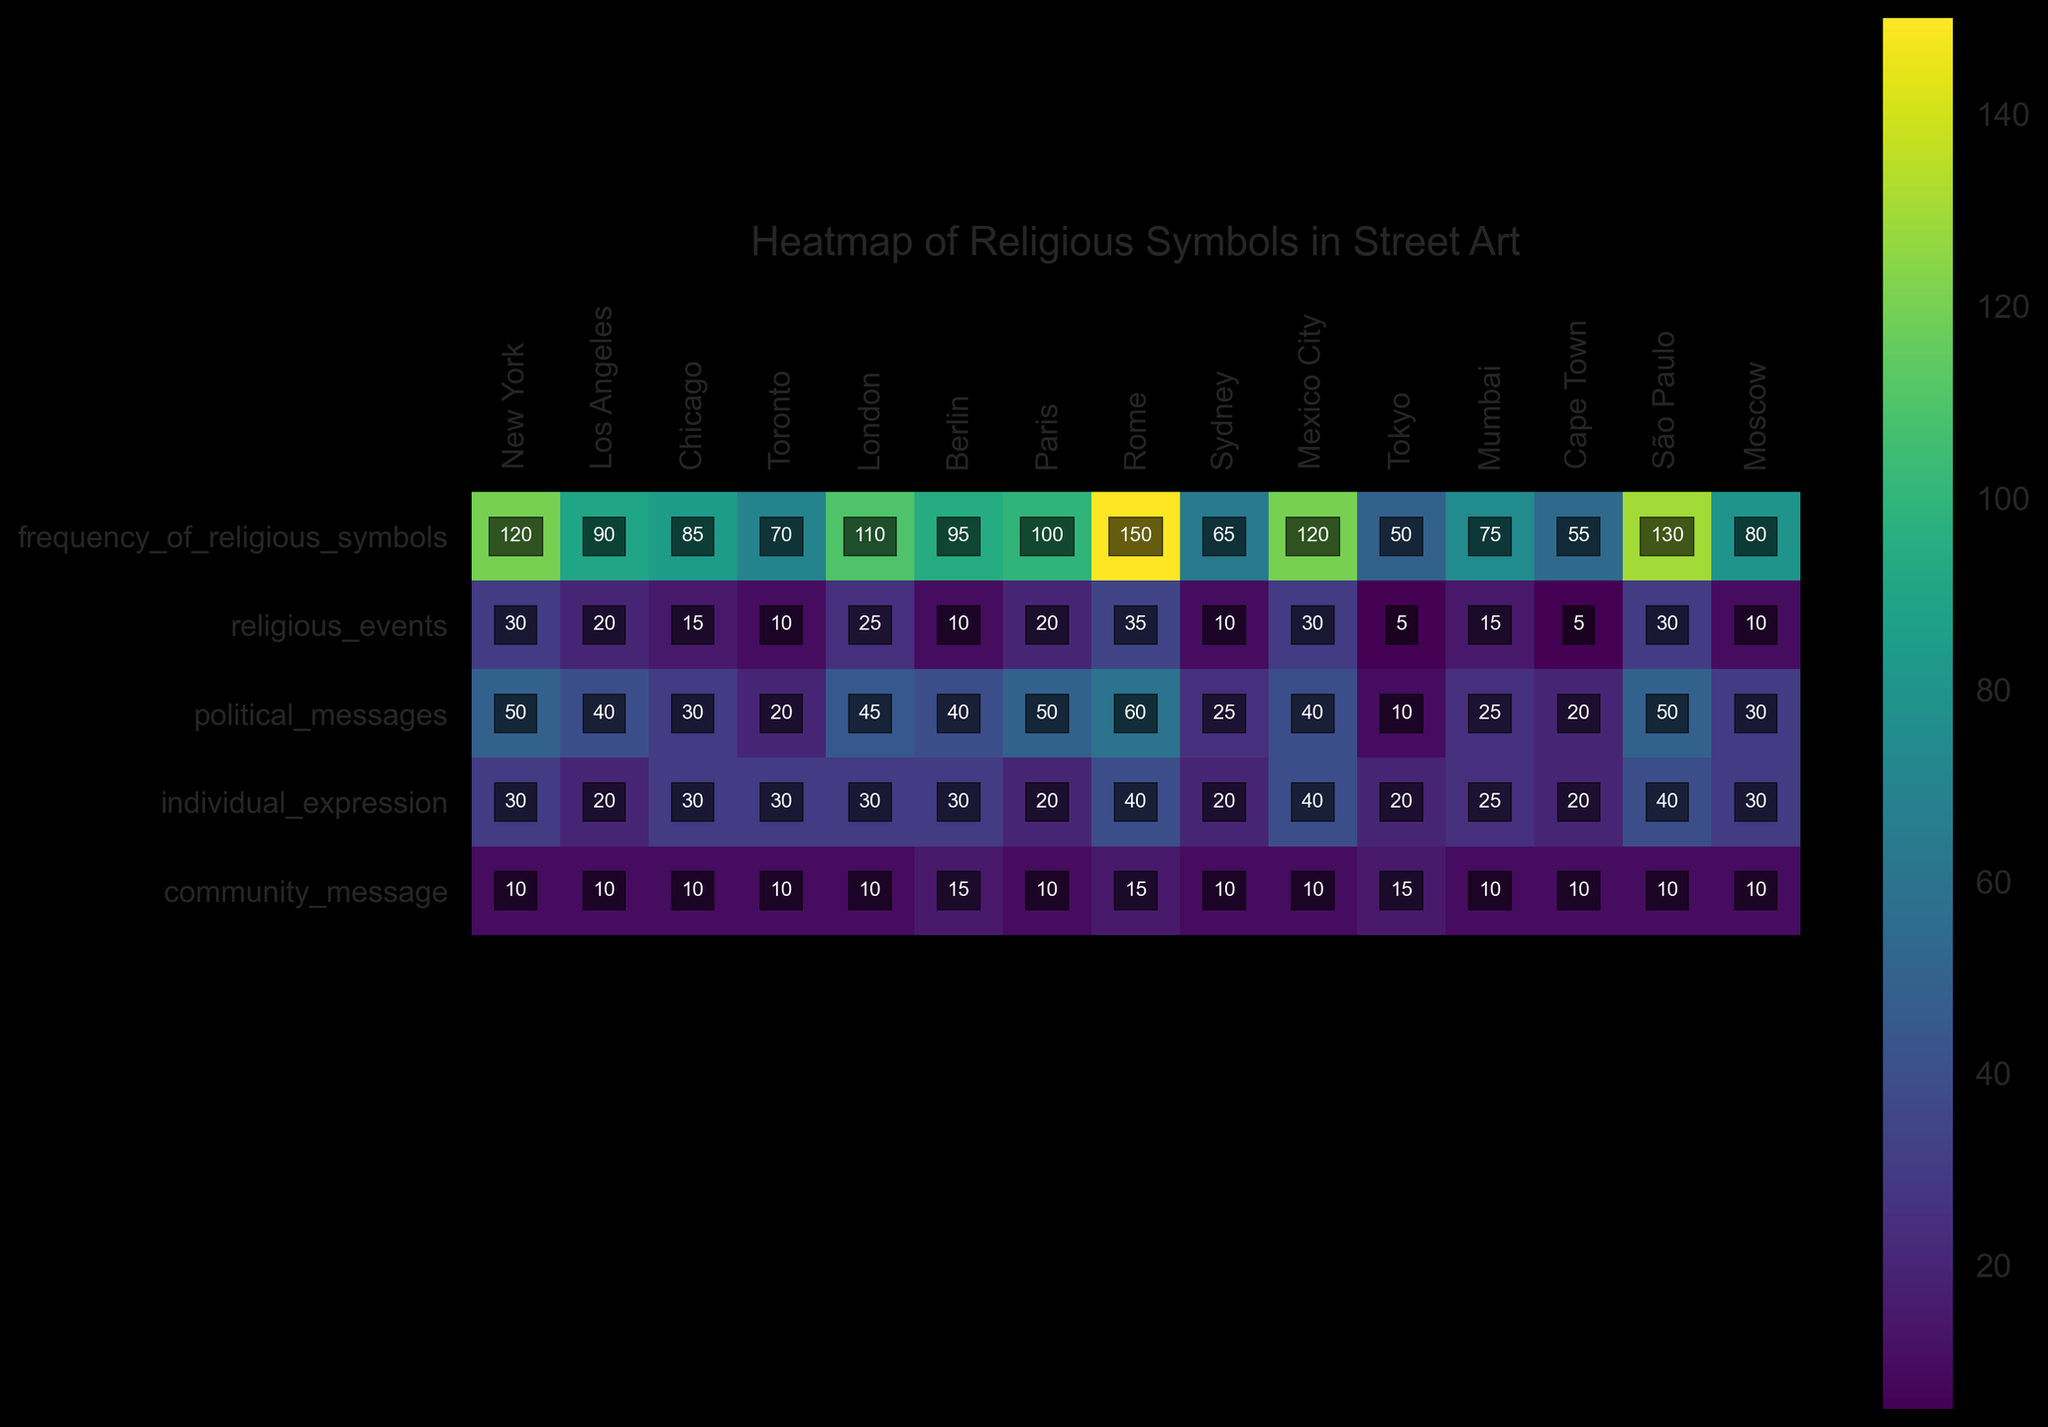Which city has the highest frequency of religious symbols in street art? To answer this, look at the 'frequency_of_religious_symbols' row and identify the city with the highest value. Rome has the highest frequency of 150.
Answer: Rome What is the average frequency of religious symbols across all cities? To get the average, sum the frequencies of religious symbols from all cities and divide by the number of cities. Summing the values: 120 + 90 + 85 + 70 + 110 + 95 + 100 + 150 + 65 + 120 + 50 + 75 + 55 + 130 + 80 = 1395. There are 15 cities, so the average is 1395 / 15 = 93.
Answer: 93 Which city has more religious symbols in street art for political messages, New York or Los Angeles? Look at the 'political_messages' row for both cities and compare the values. New York has 50 while Los Angeles has 40. Therefore, New York has more.
Answer: New York How does the use of religious symbols for community messages compare between Sydney and Tokyo? Look at the 'community_message' row for both cities and compare the values. Both Sydney and Tokyo have a value of 10.
Answer: They are the same What is the total frequency of religious symbols used for individual expression across all cities? Sum the values in the 'individual_expression' row across all cities. 30 + 20 + 30 + 30 + 30 + 30 + 20 + 40 + 20 + 40 + 20 + 25 + 20 + 40 + 30 = 395.
Answer: 395 Which city shows the highest versatility in the usage contexts of religious symbols in street art? (Hint: look for the most even distribution across contexts) Evaluate which city has the most balanced (nearly equal) numbers across the different usage contexts. Berlin has values of 10, 30, 30, and 15, showing the most even distribution compared to others.
Answer: Berlin In which context is the frequency of religious symbols lowest in Cape Town? Look at Cape Town's values across the different contexts and identify the lowest value. Cape Town has 'religious_events: 5', 'political_messages: 20', 'individual_expression: 20', and 'community_message: 10'. Thus, the lowest is 'religious_events' with 5.
Answer: Religious events 